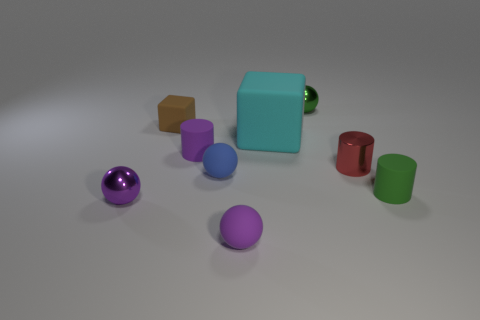Subtract 1 spheres. How many spheres are left? 3 Add 1 purple metal balls. How many objects exist? 10 Subtract all balls. How many objects are left? 5 Subtract 1 red cylinders. How many objects are left? 8 Subtract all tiny purple matte objects. Subtract all small green rubber spheres. How many objects are left? 7 Add 6 small blue matte things. How many small blue matte things are left? 7 Add 1 green rubber cylinders. How many green rubber cylinders exist? 2 